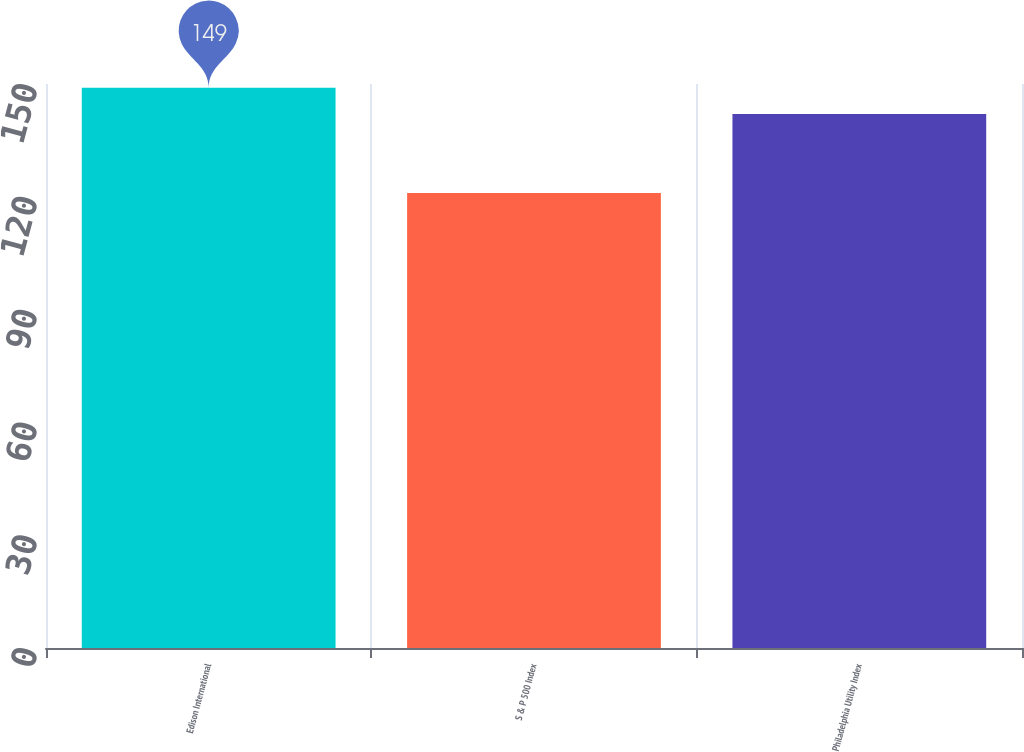<chart> <loc_0><loc_0><loc_500><loc_500><bar_chart><fcel>Edison International<fcel>S & P 500 Index<fcel>Philadelphia Utility Index<nl><fcel>149<fcel>121<fcel>142<nl></chart> 